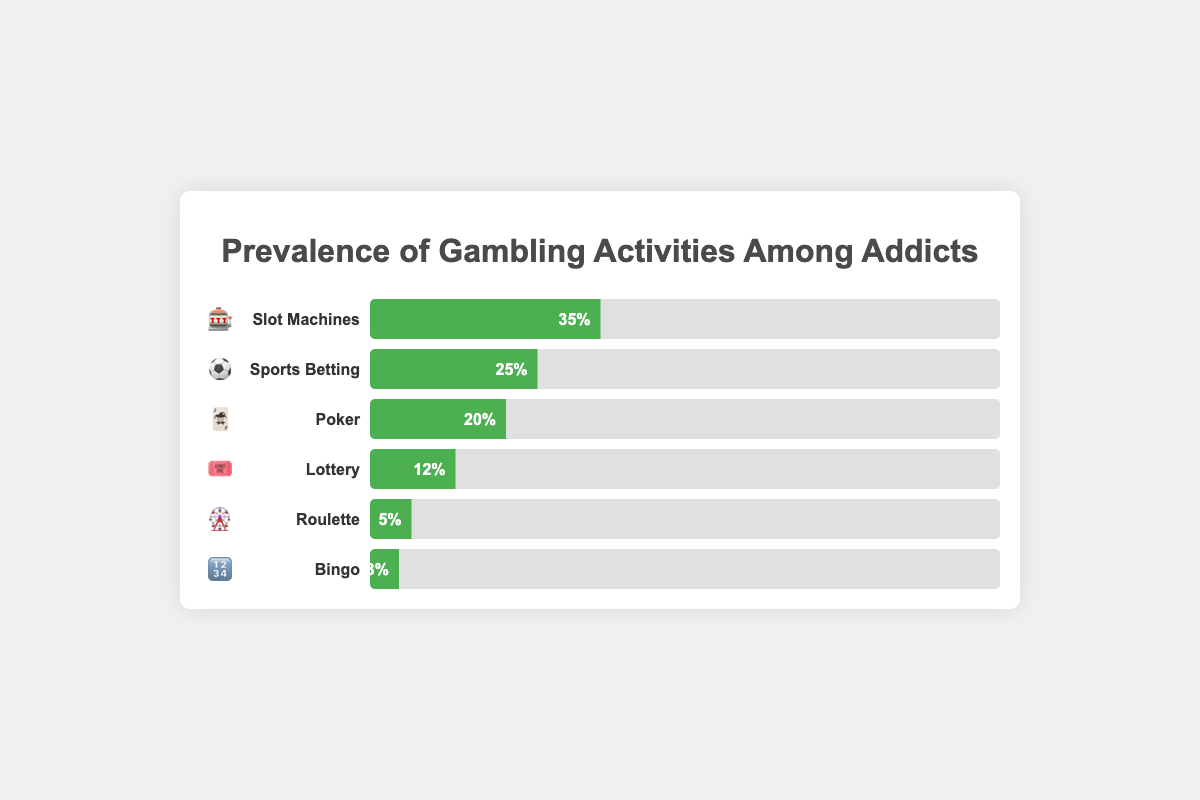Which gambling activity is most prevalent among addicts according to the chart? The bar with the longest progress bar indicates the most prevalent activity. 🎰 Slot Machines have the longest bar with 35% prevalence.
Answer: Slot Machines (🎰) What is the prevalence of Sports Betting among addicts? Look for the bar associated with ⚽ and read its value. The prevalence for ⚽ Sports Betting is shown as 25%.
Answer: 25% How much higher is the prevalence of Poker than Bingo? Find the prevalence for both 🎃 Poker and 🔢 Bingo, then subtract the smaller percentage from the larger one (20% - 3% = 17%).
Answer: 17% Which activity has a lower prevalence: Lottery or Roulette? Compare the lengths of the bars for 🎟️ Lottery and 🎡 Roulette. The value for 🎡 Roulette (5%) is smaller than 🎟️ Lottery (12%).
Answer: Roulette (🎡) What is the combined prevalence of Lottery and Roulette? Add the prevalence percentages for 🎟️ Lottery (12%) and 🎡 Roulette (5%) to get the total (12% + 5% = 17%).
Answer: 17% Rank the activities from highest to lowest prevalence. Order the activities based on the length of their bars from longest to shortest: 🎰 (35%), ⚽ (25%), 🃏 (20%), 🎟️ (12%), 🎡 (5%), 🔢 (3%).
Answer: Slot Machines (🎰) > Sports Betting (⚽) > Poker (🃏) > Lottery (🎟️) > Roulette (🎡) > Bingo (🔢) Which activity's prevalence is closest to the average prevalence of all activities? Calculate the average prevalence: (35% + 25% + 20% + 12% + 5% + 3%) / 6 = 16.67%. Compare each activity's prevalence to this value; 🃏 Poker (20%) is the closest to the average.
Answer: Poker (🃏) 